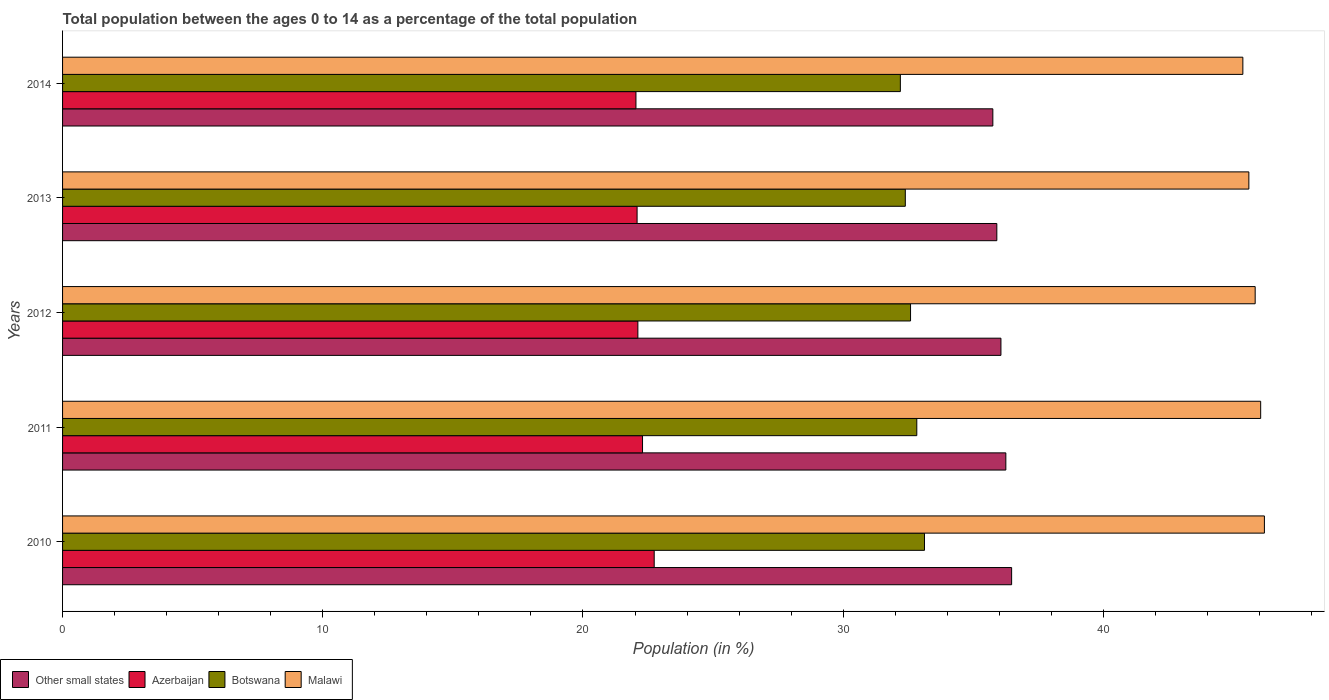Are the number of bars per tick equal to the number of legend labels?
Ensure brevity in your answer.  Yes. Are the number of bars on each tick of the Y-axis equal?
Keep it short and to the point. Yes. What is the percentage of the population ages 0 to 14 in Malawi in 2014?
Offer a very short reply. 45.36. Across all years, what is the maximum percentage of the population ages 0 to 14 in Malawi?
Offer a very short reply. 46.19. Across all years, what is the minimum percentage of the population ages 0 to 14 in Other small states?
Give a very brief answer. 35.75. What is the total percentage of the population ages 0 to 14 in Other small states in the graph?
Your response must be concise. 180.45. What is the difference between the percentage of the population ages 0 to 14 in Malawi in 2010 and that in 2014?
Offer a terse response. 0.83. What is the difference between the percentage of the population ages 0 to 14 in Botswana in 2014 and the percentage of the population ages 0 to 14 in Azerbaijan in 2013?
Your answer should be compact. 10.12. What is the average percentage of the population ages 0 to 14 in Other small states per year?
Make the answer very short. 36.09. In the year 2010, what is the difference between the percentage of the population ages 0 to 14 in Azerbaijan and percentage of the population ages 0 to 14 in Malawi?
Provide a succinct answer. -23.45. In how many years, is the percentage of the population ages 0 to 14 in Other small states greater than 4 ?
Your answer should be very brief. 5. What is the ratio of the percentage of the population ages 0 to 14 in Azerbaijan in 2012 to that in 2013?
Your response must be concise. 1. What is the difference between the highest and the second highest percentage of the population ages 0 to 14 in Malawi?
Make the answer very short. 0.14. What is the difference between the highest and the lowest percentage of the population ages 0 to 14 in Malawi?
Ensure brevity in your answer.  0.83. Is it the case that in every year, the sum of the percentage of the population ages 0 to 14 in Malawi and percentage of the population ages 0 to 14 in Azerbaijan is greater than the sum of percentage of the population ages 0 to 14 in Other small states and percentage of the population ages 0 to 14 in Botswana?
Provide a short and direct response. No. What does the 3rd bar from the top in 2013 represents?
Provide a short and direct response. Azerbaijan. What does the 4th bar from the bottom in 2013 represents?
Make the answer very short. Malawi. Is it the case that in every year, the sum of the percentage of the population ages 0 to 14 in Azerbaijan and percentage of the population ages 0 to 14 in Botswana is greater than the percentage of the population ages 0 to 14 in Other small states?
Your answer should be very brief. Yes. How many bars are there?
Make the answer very short. 20. How many years are there in the graph?
Offer a terse response. 5. Are the values on the major ticks of X-axis written in scientific E-notation?
Provide a short and direct response. No. Does the graph contain any zero values?
Make the answer very short. No. How are the legend labels stacked?
Give a very brief answer. Horizontal. What is the title of the graph?
Make the answer very short. Total population between the ages 0 to 14 as a percentage of the total population. What is the label or title of the X-axis?
Offer a terse response. Population (in %). What is the Population (in %) of Other small states in 2010?
Keep it short and to the point. 36.47. What is the Population (in %) in Azerbaijan in 2010?
Make the answer very short. 22.74. What is the Population (in %) in Botswana in 2010?
Provide a short and direct response. 33.12. What is the Population (in %) of Malawi in 2010?
Offer a terse response. 46.19. What is the Population (in %) of Other small states in 2011?
Offer a very short reply. 36.25. What is the Population (in %) in Azerbaijan in 2011?
Give a very brief answer. 22.29. What is the Population (in %) of Botswana in 2011?
Give a very brief answer. 32.83. What is the Population (in %) in Malawi in 2011?
Make the answer very short. 46.05. What is the Population (in %) of Other small states in 2012?
Offer a very short reply. 36.06. What is the Population (in %) of Azerbaijan in 2012?
Keep it short and to the point. 22.11. What is the Population (in %) of Botswana in 2012?
Your answer should be compact. 32.59. What is the Population (in %) of Malawi in 2012?
Provide a short and direct response. 45.83. What is the Population (in %) in Other small states in 2013?
Ensure brevity in your answer.  35.91. What is the Population (in %) in Azerbaijan in 2013?
Provide a succinct answer. 22.08. What is the Population (in %) of Botswana in 2013?
Your answer should be compact. 32.39. What is the Population (in %) in Malawi in 2013?
Provide a succinct answer. 45.59. What is the Population (in %) of Other small states in 2014?
Provide a short and direct response. 35.75. What is the Population (in %) in Azerbaijan in 2014?
Provide a succinct answer. 22.04. What is the Population (in %) of Botswana in 2014?
Provide a short and direct response. 32.2. What is the Population (in %) of Malawi in 2014?
Offer a very short reply. 45.36. Across all years, what is the maximum Population (in %) of Other small states?
Your answer should be compact. 36.47. Across all years, what is the maximum Population (in %) in Azerbaijan?
Offer a very short reply. 22.74. Across all years, what is the maximum Population (in %) in Botswana?
Your answer should be very brief. 33.12. Across all years, what is the maximum Population (in %) of Malawi?
Provide a succinct answer. 46.19. Across all years, what is the minimum Population (in %) of Other small states?
Your answer should be compact. 35.75. Across all years, what is the minimum Population (in %) in Azerbaijan?
Keep it short and to the point. 22.04. Across all years, what is the minimum Population (in %) in Botswana?
Your answer should be very brief. 32.2. Across all years, what is the minimum Population (in %) of Malawi?
Your answer should be very brief. 45.36. What is the total Population (in %) in Other small states in the graph?
Ensure brevity in your answer.  180.45. What is the total Population (in %) in Azerbaijan in the graph?
Offer a terse response. 111.25. What is the total Population (in %) of Botswana in the graph?
Make the answer very short. 163.13. What is the total Population (in %) in Malawi in the graph?
Give a very brief answer. 229.02. What is the difference between the Population (in %) in Other small states in 2010 and that in 2011?
Your answer should be very brief. 0.22. What is the difference between the Population (in %) of Azerbaijan in 2010 and that in 2011?
Keep it short and to the point. 0.45. What is the difference between the Population (in %) in Botswana in 2010 and that in 2011?
Keep it short and to the point. 0.29. What is the difference between the Population (in %) in Malawi in 2010 and that in 2011?
Offer a very short reply. 0.14. What is the difference between the Population (in %) in Other small states in 2010 and that in 2012?
Provide a short and direct response. 0.41. What is the difference between the Population (in %) of Azerbaijan in 2010 and that in 2012?
Keep it short and to the point. 0.63. What is the difference between the Population (in %) in Botswana in 2010 and that in 2012?
Provide a short and direct response. 0.54. What is the difference between the Population (in %) in Malawi in 2010 and that in 2012?
Offer a very short reply. 0.35. What is the difference between the Population (in %) of Other small states in 2010 and that in 2013?
Provide a short and direct response. 0.57. What is the difference between the Population (in %) of Azerbaijan in 2010 and that in 2013?
Provide a succinct answer. 0.66. What is the difference between the Population (in %) of Botswana in 2010 and that in 2013?
Offer a terse response. 0.74. What is the difference between the Population (in %) of Malawi in 2010 and that in 2013?
Keep it short and to the point. 0.6. What is the difference between the Population (in %) of Other small states in 2010 and that in 2014?
Provide a short and direct response. 0.72. What is the difference between the Population (in %) of Azerbaijan in 2010 and that in 2014?
Your response must be concise. 0.7. What is the difference between the Population (in %) of Botswana in 2010 and that in 2014?
Your response must be concise. 0.93. What is the difference between the Population (in %) in Malawi in 2010 and that in 2014?
Provide a short and direct response. 0.83. What is the difference between the Population (in %) in Other small states in 2011 and that in 2012?
Your answer should be very brief. 0.19. What is the difference between the Population (in %) of Azerbaijan in 2011 and that in 2012?
Keep it short and to the point. 0.18. What is the difference between the Population (in %) in Botswana in 2011 and that in 2012?
Provide a short and direct response. 0.24. What is the difference between the Population (in %) in Malawi in 2011 and that in 2012?
Your response must be concise. 0.21. What is the difference between the Population (in %) in Other small states in 2011 and that in 2013?
Offer a terse response. 0.35. What is the difference between the Population (in %) of Azerbaijan in 2011 and that in 2013?
Offer a very short reply. 0.21. What is the difference between the Population (in %) in Botswana in 2011 and that in 2013?
Provide a short and direct response. 0.44. What is the difference between the Population (in %) in Malawi in 2011 and that in 2013?
Ensure brevity in your answer.  0.45. What is the difference between the Population (in %) of Other small states in 2011 and that in 2014?
Keep it short and to the point. 0.5. What is the difference between the Population (in %) in Azerbaijan in 2011 and that in 2014?
Provide a succinct answer. 0.25. What is the difference between the Population (in %) in Botswana in 2011 and that in 2014?
Offer a terse response. 0.63. What is the difference between the Population (in %) of Malawi in 2011 and that in 2014?
Your response must be concise. 0.68. What is the difference between the Population (in %) in Other small states in 2012 and that in 2013?
Provide a succinct answer. 0.16. What is the difference between the Population (in %) of Azerbaijan in 2012 and that in 2013?
Offer a very short reply. 0.03. What is the difference between the Population (in %) of Botswana in 2012 and that in 2013?
Your answer should be very brief. 0.2. What is the difference between the Population (in %) in Malawi in 2012 and that in 2013?
Provide a short and direct response. 0.24. What is the difference between the Population (in %) in Other small states in 2012 and that in 2014?
Provide a succinct answer. 0.31. What is the difference between the Population (in %) of Azerbaijan in 2012 and that in 2014?
Provide a short and direct response. 0.07. What is the difference between the Population (in %) in Botswana in 2012 and that in 2014?
Make the answer very short. 0.39. What is the difference between the Population (in %) of Malawi in 2012 and that in 2014?
Make the answer very short. 0.47. What is the difference between the Population (in %) of Other small states in 2013 and that in 2014?
Give a very brief answer. 0.15. What is the difference between the Population (in %) in Azerbaijan in 2013 and that in 2014?
Offer a very short reply. 0.04. What is the difference between the Population (in %) of Botswana in 2013 and that in 2014?
Ensure brevity in your answer.  0.19. What is the difference between the Population (in %) of Malawi in 2013 and that in 2014?
Provide a succinct answer. 0.23. What is the difference between the Population (in %) of Other small states in 2010 and the Population (in %) of Azerbaijan in 2011?
Provide a succinct answer. 14.19. What is the difference between the Population (in %) in Other small states in 2010 and the Population (in %) in Botswana in 2011?
Your answer should be very brief. 3.64. What is the difference between the Population (in %) in Other small states in 2010 and the Population (in %) in Malawi in 2011?
Offer a very short reply. -9.57. What is the difference between the Population (in %) of Azerbaijan in 2010 and the Population (in %) of Botswana in 2011?
Offer a terse response. -10.09. What is the difference between the Population (in %) in Azerbaijan in 2010 and the Population (in %) in Malawi in 2011?
Give a very brief answer. -23.31. What is the difference between the Population (in %) in Botswana in 2010 and the Population (in %) in Malawi in 2011?
Keep it short and to the point. -12.92. What is the difference between the Population (in %) of Other small states in 2010 and the Population (in %) of Azerbaijan in 2012?
Offer a very short reply. 14.36. What is the difference between the Population (in %) in Other small states in 2010 and the Population (in %) in Botswana in 2012?
Offer a very short reply. 3.88. What is the difference between the Population (in %) in Other small states in 2010 and the Population (in %) in Malawi in 2012?
Give a very brief answer. -9.36. What is the difference between the Population (in %) in Azerbaijan in 2010 and the Population (in %) in Botswana in 2012?
Give a very brief answer. -9.85. What is the difference between the Population (in %) of Azerbaijan in 2010 and the Population (in %) of Malawi in 2012?
Your answer should be very brief. -23.1. What is the difference between the Population (in %) in Botswana in 2010 and the Population (in %) in Malawi in 2012?
Offer a very short reply. -12.71. What is the difference between the Population (in %) of Other small states in 2010 and the Population (in %) of Azerbaijan in 2013?
Your answer should be very brief. 14.39. What is the difference between the Population (in %) in Other small states in 2010 and the Population (in %) in Botswana in 2013?
Provide a succinct answer. 4.09. What is the difference between the Population (in %) in Other small states in 2010 and the Population (in %) in Malawi in 2013?
Your response must be concise. -9.12. What is the difference between the Population (in %) in Azerbaijan in 2010 and the Population (in %) in Botswana in 2013?
Provide a short and direct response. -9.65. What is the difference between the Population (in %) in Azerbaijan in 2010 and the Population (in %) in Malawi in 2013?
Your answer should be compact. -22.85. What is the difference between the Population (in %) of Botswana in 2010 and the Population (in %) of Malawi in 2013?
Provide a short and direct response. -12.47. What is the difference between the Population (in %) of Other small states in 2010 and the Population (in %) of Azerbaijan in 2014?
Your response must be concise. 14.44. What is the difference between the Population (in %) of Other small states in 2010 and the Population (in %) of Botswana in 2014?
Keep it short and to the point. 4.28. What is the difference between the Population (in %) of Other small states in 2010 and the Population (in %) of Malawi in 2014?
Offer a very short reply. -8.89. What is the difference between the Population (in %) in Azerbaijan in 2010 and the Population (in %) in Botswana in 2014?
Your response must be concise. -9.46. What is the difference between the Population (in %) in Azerbaijan in 2010 and the Population (in %) in Malawi in 2014?
Provide a short and direct response. -22.62. What is the difference between the Population (in %) in Botswana in 2010 and the Population (in %) in Malawi in 2014?
Offer a terse response. -12.24. What is the difference between the Population (in %) of Other small states in 2011 and the Population (in %) of Azerbaijan in 2012?
Offer a terse response. 14.14. What is the difference between the Population (in %) in Other small states in 2011 and the Population (in %) in Botswana in 2012?
Ensure brevity in your answer.  3.66. What is the difference between the Population (in %) in Other small states in 2011 and the Population (in %) in Malawi in 2012?
Keep it short and to the point. -9.58. What is the difference between the Population (in %) of Azerbaijan in 2011 and the Population (in %) of Botswana in 2012?
Provide a succinct answer. -10.3. What is the difference between the Population (in %) in Azerbaijan in 2011 and the Population (in %) in Malawi in 2012?
Your answer should be very brief. -23.55. What is the difference between the Population (in %) of Botswana in 2011 and the Population (in %) of Malawi in 2012?
Your response must be concise. -13. What is the difference between the Population (in %) of Other small states in 2011 and the Population (in %) of Azerbaijan in 2013?
Make the answer very short. 14.17. What is the difference between the Population (in %) of Other small states in 2011 and the Population (in %) of Botswana in 2013?
Your answer should be very brief. 3.86. What is the difference between the Population (in %) in Other small states in 2011 and the Population (in %) in Malawi in 2013?
Keep it short and to the point. -9.34. What is the difference between the Population (in %) in Azerbaijan in 2011 and the Population (in %) in Botswana in 2013?
Give a very brief answer. -10.1. What is the difference between the Population (in %) of Azerbaijan in 2011 and the Population (in %) of Malawi in 2013?
Offer a terse response. -23.3. What is the difference between the Population (in %) of Botswana in 2011 and the Population (in %) of Malawi in 2013?
Keep it short and to the point. -12.76. What is the difference between the Population (in %) of Other small states in 2011 and the Population (in %) of Azerbaijan in 2014?
Offer a terse response. 14.22. What is the difference between the Population (in %) in Other small states in 2011 and the Population (in %) in Botswana in 2014?
Your answer should be very brief. 4.05. What is the difference between the Population (in %) of Other small states in 2011 and the Population (in %) of Malawi in 2014?
Offer a terse response. -9.11. What is the difference between the Population (in %) in Azerbaijan in 2011 and the Population (in %) in Botswana in 2014?
Your answer should be compact. -9.91. What is the difference between the Population (in %) in Azerbaijan in 2011 and the Population (in %) in Malawi in 2014?
Give a very brief answer. -23.07. What is the difference between the Population (in %) of Botswana in 2011 and the Population (in %) of Malawi in 2014?
Make the answer very short. -12.53. What is the difference between the Population (in %) in Other small states in 2012 and the Population (in %) in Azerbaijan in 2013?
Keep it short and to the point. 13.98. What is the difference between the Population (in %) of Other small states in 2012 and the Population (in %) of Botswana in 2013?
Make the answer very short. 3.68. What is the difference between the Population (in %) of Other small states in 2012 and the Population (in %) of Malawi in 2013?
Provide a succinct answer. -9.53. What is the difference between the Population (in %) in Azerbaijan in 2012 and the Population (in %) in Botswana in 2013?
Offer a very short reply. -10.28. What is the difference between the Population (in %) of Azerbaijan in 2012 and the Population (in %) of Malawi in 2013?
Your answer should be compact. -23.48. What is the difference between the Population (in %) of Botswana in 2012 and the Population (in %) of Malawi in 2013?
Your response must be concise. -13. What is the difference between the Population (in %) of Other small states in 2012 and the Population (in %) of Azerbaijan in 2014?
Ensure brevity in your answer.  14.03. What is the difference between the Population (in %) of Other small states in 2012 and the Population (in %) of Botswana in 2014?
Offer a very short reply. 3.87. What is the difference between the Population (in %) of Other small states in 2012 and the Population (in %) of Malawi in 2014?
Offer a terse response. -9.3. What is the difference between the Population (in %) of Azerbaijan in 2012 and the Population (in %) of Botswana in 2014?
Offer a very short reply. -10.09. What is the difference between the Population (in %) of Azerbaijan in 2012 and the Population (in %) of Malawi in 2014?
Your answer should be very brief. -23.25. What is the difference between the Population (in %) of Botswana in 2012 and the Population (in %) of Malawi in 2014?
Offer a terse response. -12.77. What is the difference between the Population (in %) in Other small states in 2013 and the Population (in %) in Azerbaijan in 2014?
Keep it short and to the point. 13.87. What is the difference between the Population (in %) in Other small states in 2013 and the Population (in %) in Botswana in 2014?
Your answer should be compact. 3.71. What is the difference between the Population (in %) in Other small states in 2013 and the Population (in %) in Malawi in 2014?
Offer a terse response. -9.46. What is the difference between the Population (in %) of Azerbaijan in 2013 and the Population (in %) of Botswana in 2014?
Make the answer very short. -10.12. What is the difference between the Population (in %) in Azerbaijan in 2013 and the Population (in %) in Malawi in 2014?
Your answer should be very brief. -23.28. What is the difference between the Population (in %) in Botswana in 2013 and the Population (in %) in Malawi in 2014?
Keep it short and to the point. -12.97. What is the average Population (in %) in Other small states per year?
Offer a very short reply. 36.09. What is the average Population (in %) of Azerbaijan per year?
Your response must be concise. 22.25. What is the average Population (in %) in Botswana per year?
Ensure brevity in your answer.  32.63. What is the average Population (in %) in Malawi per year?
Offer a very short reply. 45.8. In the year 2010, what is the difference between the Population (in %) of Other small states and Population (in %) of Azerbaijan?
Your response must be concise. 13.74. In the year 2010, what is the difference between the Population (in %) of Other small states and Population (in %) of Botswana?
Ensure brevity in your answer.  3.35. In the year 2010, what is the difference between the Population (in %) in Other small states and Population (in %) in Malawi?
Your response must be concise. -9.71. In the year 2010, what is the difference between the Population (in %) of Azerbaijan and Population (in %) of Botswana?
Provide a short and direct response. -10.39. In the year 2010, what is the difference between the Population (in %) of Azerbaijan and Population (in %) of Malawi?
Provide a short and direct response. -23.45. In the year 2010, what is the difference between the Population (in %) of Botswana and Population (in %) of Malawi?
Your response must be concise. -13.06. In the year 2011, what is the difference between the Population (in %) in Other small states and Population (in %) in Azerbaijan?
Give a very brief answer. 13.96. In the year 2011, what is the difference between the Population (in %) of Other small states and Population (in %) of Botswana?
Your response must be concise. 3.42. In the year 2011, what is the difference between the Population (in %) of Other small states and Population (in %) of Malawi?
Your answer should be very brief. -9.79. In the year 2011, what is the difference between the Population (in %) in Azerbaijan and Population (in %) in Botswana?
Offer a very short reply. -10.54. In the year 2011, what is the difference between the Population (in %) of Azerbaijan and Population (in %) of Malawi?
Offer a terse response. -23.76. In the year 2011, what is the difference between the Population (in %) in Botswana and Population (in %) in Malawi?
Ensure brevity in your answer.  -13.22. In the year 2012, what is the difference between the Population (in %) in Other small states and Population (in %) in Azerbaijan?
Your answer should be compact. 13.95. In the year 2012, what is the difference between the Population (in %) in Other small states and Population (in %) in Botswana?
Your answer should be very brief. 3.47. In the year 2012, what is the difference between the Population (in %) of Other small states and Population (in %) of Malawi?
Keep it short and to the point. -9.77. In the year 2012, what is the difference between the Population (in %) of Azerbaijan and Population (in %) of Botswana?
Keep it short and to the point. -10.48. In the year 2012, what is the difference between the Population (in %) in Azerbaijan and Population (in %) in Malawi?
Ensure brevity in your answer.  -23.72. In the year 2012, what is the difference between the Population (in %) of Botswana and Population (in %) of Malawi?
Your response must be concise. -13.24. In the year 2013, what is the difference between the Population (in %) in Other small states and Population (in %) in Azerbaijan?
Your answer should be very brief. 13.83. In the year 2013, what is the difference between the Population (in %) of Other small states and Population (in %) of Botswana?
Your answer should be very brief. 3.52. In the year 2013, what is the difference between the Population (in %) of Other small states and Population (in %) of Malawi?
Offer a terse response. -9.69. In the year 2013, what is the difference between the Population (in %) in Azerbaijan and Population (in %) in Botswana?
Offer a very short reply. -10.31. In the year 2013, what is the difference between the Population (in %) in Azerbaijan and Population (in %) in Malawi?
Provide a succinct answer. -23.51. In the year 2013, what is the difference between the Population (in %) of Botswana and Population (in %) of Malawi?
Offer a terse response. -13.2. In the year 2014, what is the difference between the Population (in %) of Other small states and Population (in %) of Azerbaijan?
Make the answer very short. 13.72. In the year 2014, what is the difference between the Population (in %) in Other small states and Population (in %) in Botswana?
Give a very brief answer. 3.55. In the year 2014, what is the difference between the Population (in %) in Other small states and Population (in %) in Malawi?
Your response must be concise. -9.61. In the year 2014, what is the difference between the Population (in %) in Azerbaijan and Population (in %) in Botswana?
Give a very brief answer. -10.16. In the year 2014, what is the difference between the Population (in %) in Azerbaijan and Population (in %) in Malawi?
Ensure brevity in your answer.  -23.32. In the year 2014, what is the difference between the Population (in %) in Botswana and Population (in %) in Malawi?
Keep it short and to the point. -13.16. What is the ratio of the Population (in %) in Azerbaijan in 2010 to that in 2011?
Keep it short and to the point. 1.02. What is the ratio of the Population (in %) in Malawi in 2010 to that in 2011?
Your response must be concise. 1. What is the ratio of the Population (in %) in Other small states in 2010 to that in 2012?
Keep it short and to the point. 1.01. What is the ratio of the Population (in %) of Azerbaijan in 2010 to that in 2012?
Keep it short and to the point. 1.03. What is the ratio of the Population (in %) in Botswana in 2010 to that in 2012?
Give a very brief answer. 1.02. What is the ratio of the Population (in %) of Malawi in 2010 to that in 2012?
Ensure brevity in your answer.  1.01. What is the ratio of the Population (in %) of Other small states in 2010 to that in 2013?
Offer a terse response. 1.02. What is the ratio of the Population (in %) in Azerbaijan in 2010 to that in 2013?
Ensure brevity in your answer.  1.03. What is the ratio of the Population (in %) of Botswana in 2010 to that in 2013?
Provide a succinct answer. 1.02. What is the ratio of the Population (in %) of Malawi in 2010 to that in 2013?
Your answer should be compact. 1.01. What is the ratio of the Population (in %) in Other small states in 2010 to that in 2014?
Provide a short and direct response. 1.02. What is the ratio of the Population (in %) of Azerbaijan in 2010 to that in 2014?
Offer a terse response. 1.03. What is the ratio of the Population (in %) in Botswana in 2010 to that in 2014?
Offer a very short reply. 1.03. What is the ratio of the Population (in %) of Malawi in 2010 to that in 2014?
Offer a very short reply. 1.02. What is the ratio of the Population (in %) in Botswana in 2011 to that in 2012?
Offer a terse response. 1.01. What is the ratio of the Population (in %) in Malawi in 2011 to that in 2012?
Your answer should be very brief. 1. What is the ratio of the Population (in %) in Other small states in 2011 to that in 2013?
Make the answer very short. 1.01. What is the ratio of the Population (in %) in Azerbaijan in 2011 to that in 2013?
Provide a short and direct response. 1.01. What is the ratio of the Population (in %) in Botswana in 2011 to that in 2013?
Make the answer very short. 1.01. What is the ratio of the Population (in %) of Azerbaijan in 2011 to that in 2014?
Provide a short and direct response. 1.01. What is the ratio of the Population (in %) of Botswana in 2011 to that in 2014?
Give a very brief answer. 1.02. What is the ratio of the Population (in %) in Malawi in 2011 to that in 2014?
Your answer should be very brief. 1.02. What is the ratio of the Population (in %) of Azerbaijan in 2012 to that in 2013?
Provide a short and direct response. 1. What is the ratio of the Population (in %) in Botswana in 2012 to that in 2013?
Offer a terse response. 1.01. What is the ratio of the Population (in %) in Malawi in 2012 to that in 2013?
Provide a short and direct response. 1.01. What is the ratio of the Population (in %) in Other small states in 2012 to that in 2014?
Keep it short and to the point. 1.01. What is the ratio of the Population (in %) of Azerbaijan in 2012 to that in 2014?
Keep it short and to the point. 1. What is the ratio of the Population (in %) of Botswana in 2012 to that in 2014?
Offer a very short reply. 1.01. What is the ratio of the Population (in %) in Malawi in 2012 to that in 2014?
Offer a very short reply. 1.01. What is the ratio of the Population (in %) of Botswana in 2013 to that in 2014?
Your answer should be compact. 1.01. What is the difference between the highest and the second highest Population (in %) of Other small states?
Offer a very short reply. 0.22. What is the difference between the highest and the second highest Population (in %) in Azerbaijan?
Provide a succinct answer. 0.45. What is the difference between the highest and the second highest Population (in %) of Botswana?
Your answer should be very brief. 0.29. What is the difference between the highest and the second highest Population (in %) in Malawi?
Your answer should be compact. 0.14. What is the difference between the highest and the lowest Population (in %) of Other small states?
Provide a succinct answer. 0.72. What is the difference between the highest and the lowest Population (in %) of Azerbaijan?
Make the answer very short. 0.7. What is the difference between the highest and the lowest Population (in %) of Botswana?
Offer a very short reply. 0.93. What is the difference between the highest and the lowest Population (in %) in Malawi?
Provide a succinct answer. 0.83. 